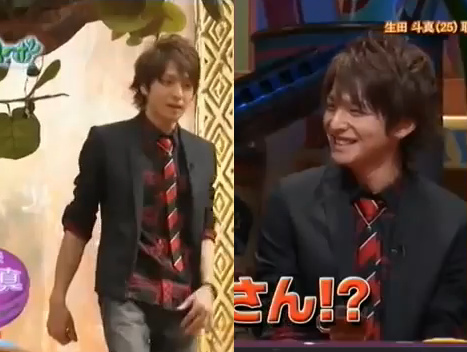Which kind of clothing is folded? The coat is folded. 